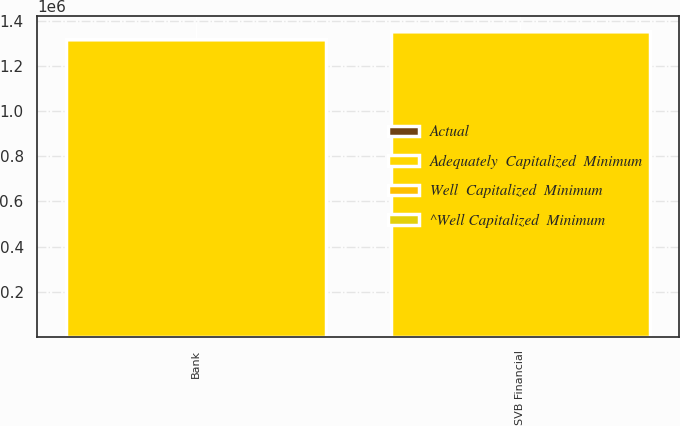Convert chart to OTSL. <chart><loc_0><loc_0><loc_500><loc_500><stacked_bar_chart><ecel><fcel>SVB Financial<fcel>Bank<nl><fcel>^Well Capitalized  Minimum<fcel>14.05<fcel>12.53<nl><fcel>Actual<fcel>10<fcel>10<nl><fcel>Well  Capitalized  Minimum<fcel>8<fcel>8<nl><fcel>Adequately  Capitalized  Minimum<fcel>1.3533e+06<fcel>1.31779e+06<nl></chart> 